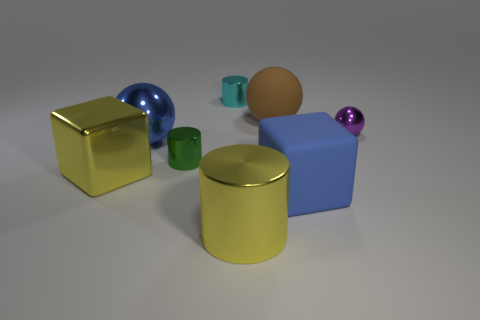There is a metal object right of the blue rubber cube; does it have the same size as the tiny cyan shiny cylinder?
Your answer should be compact. Yes. Is there anything else that is the same size as the yellow cube?
Keep it short and to the point. Yes. What is the size of the yellow object that is the same shape as the small cyan thing?
Make the answer very short. Large. Is the number of large rubber blocks on the left side of the yellow block the same as the number of rubber balls that are behind the big brown sphere?
Provide a short and direct response. Yes. What is the size of the cube that is to the right of the metallic block?
Give a very brief answer. Large. Does the big metal block have the same color as the tiny sphere?
Offer a terse response. No. Are there any other things that have the same shape as the big brown matte object?
Your response must be concise. Yes. There is a ball that is the same color as the big matte cube; what is its material?
Provide a succinct answer. Metal. Is the number of blue metallic objects that are right of the purple sphere the same as the number of small gray rubber cylinders?
Make the answer very short. Yes. There is a cyan cylinder; are there any small spheres to the right of it?
Make the answer very short. Yes. 